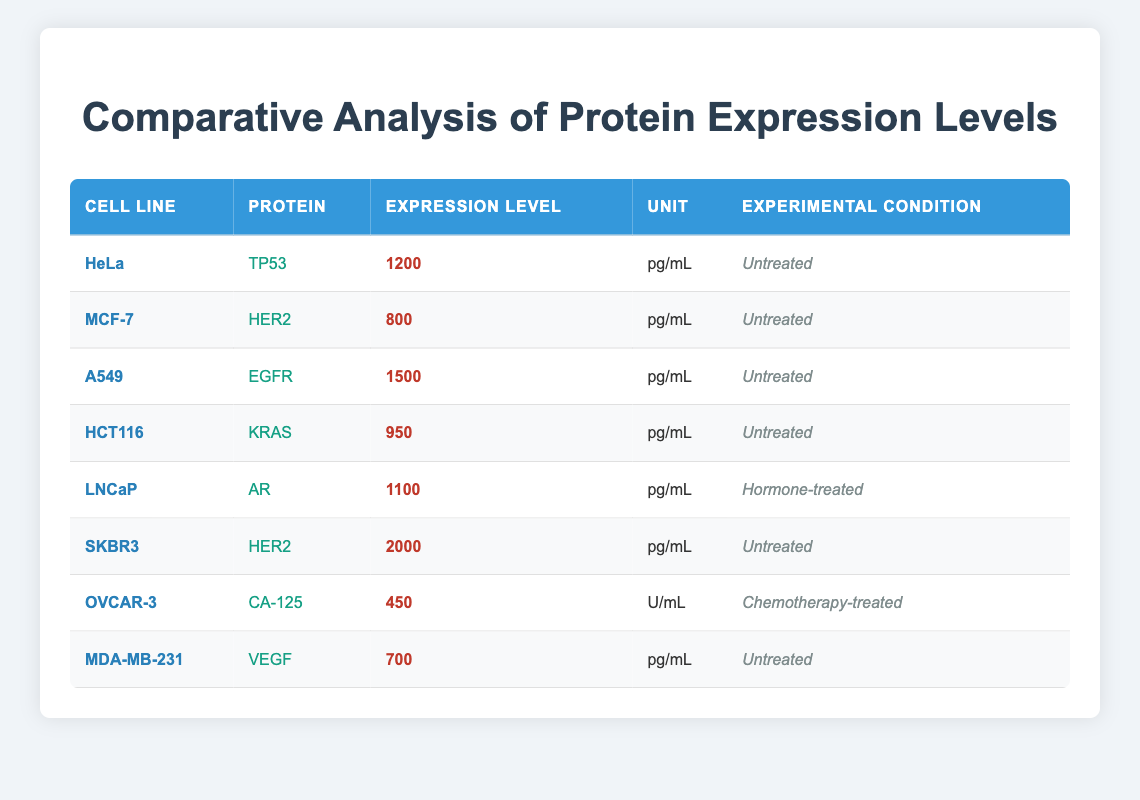What is the expression level of TP53 in HeLa cells? The table indicates that the expression level of TP53 in HeLa cells is 1200 pg/mL as it is listed in the row corresponding to HeLa in the protein column.
Answer: 1200 pg/mL Which protein has the highest expression level and in which cell line? By examining the expression levels in the table, EGFR has the highest value of 1500 pg/mL, found in A549 cell line.
Answer: EGFR in A549 Is the expression level of HER2 in SKBR3 higher than in MCF-7? In the table, the expression level of HER2 in SKBR3 is 2000 pg/mL, while in MCF-7 it is 800 pg/mL. Since 2000 is greater than 800, the statement is true.
Answer: Yes What is the average expression level of proteins in untreated conditions? The table lists expression levels in untreated conditions as follows: TP53 (1200), HER2 (800), EGFR (1500), KRAS (950), and VEGF (700). The sum is 1200 + 800 + 1500 + 950 + 700 = 4150. There are 5 data points, so the average is 4150/5 = 830.
Answer: 830 pg/mL Does the expression level of CA-125 in OVCAR-3 exceed 500 U/mL? In the table, CA-125 is listed at 450 U/mL for OVCAR-3, which is less than 500 U/mL. Therefore, this statement is false.
Answer: No What is the difference in expression levels between SKBR3 and MDA-MB-231? In SKBR3, HER2 has an expression of 2000 pg/mL, while in MDA-MB-231, VEGF has an expression of 700 pg/mL. The difference is calculated as 2000 - 700 = 1300 pg/mL.
Answer: 1300 pg/mL Which cell line shows the lowest expression level of proteins and what is the value? Looking through the table, OVCAR-3 has the lowest expression level of CA-125 at 450 U/mL.
Answer: OVCAR-3, 450 U/mL What percentage of the total expression level of proteins in treated and untreated conditions does the expression of AR in LNCaP represent? The only treated condition listed is for LNCaP (1100 pg/mL). The total for untreated proteins is 4150 pg/mL. The percentage is calculated as (1100 / (4150 + 1100)) * 100 = (1100 / 5250) * 100 ≈ 20.95%.
Answer: 20.95% 